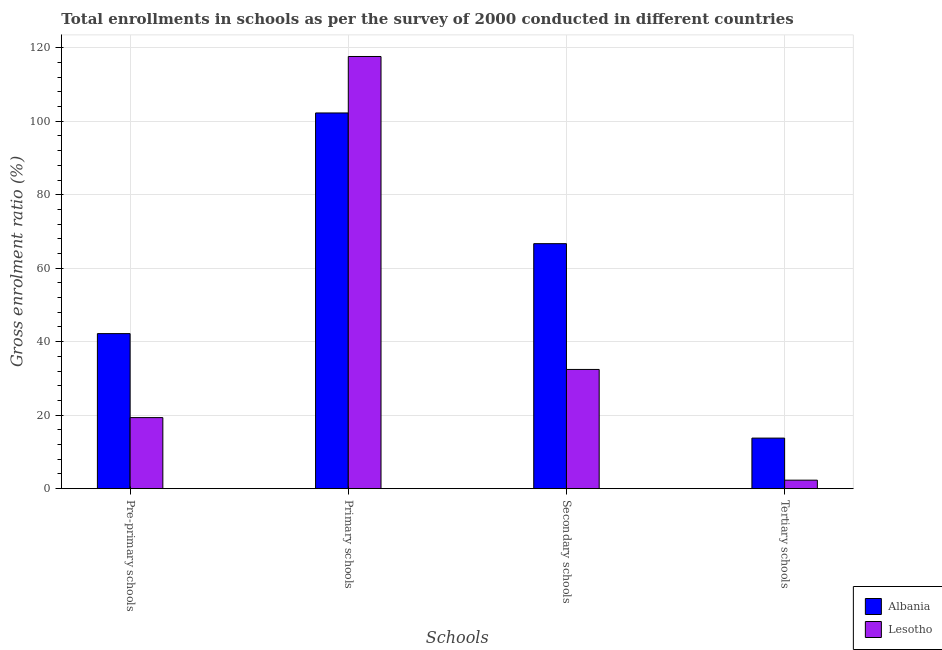How many groups of bars are there?
Keep it short and to the point. 4. Are the number of bars on each tick of the X-axis equal?
Your response must be concise. Yes. How many bars are there on the 4th tick from the right?
Your answer should be compact. 2. What is the label of the 2nd group of bars from the left?
Ensure brevity in your answer.  Primary schools. What is the gross enrolment ratio in secondary schools in Lesotho?
Make the answer very short. 32.45. Across all countries, what is the maximum gross enrolment ratio in pre-primary schools?
Offer a very short reply. 42.2. Across all countries, what is the minimum gross enrolment ratio in pre-primary schools?
Give a very brief answer. 19.34. In which country was the gross enrolment ratio in pre-primary schools maximum?
Give a very brief answer. Albania. In which country was the gross enrolment ratio in tertiary schools minimum?
Offer a terse response. Lesotho. What is the total gross enrolment ratio in primary schools in the graph?
Your answer should be very brief. 219.87. What is the difference between the gross enrolment ratio in secondary schools in Lesotho and that in Albania?
Your answer should be compact. -34.23. What is the difference between the gross enrolment ratio in pre-primary schools in Lesotho and the gross enrolment ratio in primary schools in Albania?
Provide a succinct answer. -82.91. What is the average gross enrolment ratio in primary schools per country?
Your answer should be compact. 109.94. What is the difference between the gross enrolment ratio in pre-primary schools and gross enrolment ratio in tertiary schools in Albania?
Provide a succinct answer. 28.44. What is the ratio of the gross enrolment ratio in primary schools in Lesotho to that in Albania?
Your answer should be compact. 1.15. Is the gross enrolment ratio in primary schools in Lesotho less than that in Albania?
Give a very brief answer. No. What is the difference between the highest and the second highest gross enrolment ratio in tertiary schools?
Make the answer very short. 11.45. What is the difference between the highest and the lowest gross enrolment ratio in secondary schools?
Your answer should be compact. 34.23. In how many countries, is the gross enrolment ratio in secondary schools greater than the average gross enrolment ratio in secondary schools taken over all countries?
Your answer should be compact. 1. Is it the case that in every country, the sum of the gross enrolment ratio in secondary schools and gross enrolment ratio in primary schools is greater than the sum of gross enrolment ratio in pre-primary schools and gross enrolment ratio in tertiary schools?
Provide a short and direct response. Yes. What does the 2nd bar from the left in Secondary schools represents?
Offer a terse response. Lesotho. What does the 1st bar from the right in Primary schools represents?
Give a very brief answer. Lesotho. Are all the bars in the graph horizontal?
Your answer should be compact. No. How many countries are there in the graph?
Make the answer very short. 2. Does the graph contain grids?
Your response must be concise. Yes. What is the title of the graph?
Ensure brevity in your answer.  Total enrollments in schools as per the survey of 2000 conducted in different countries. Does "Djibouti" appear as one of the legend labels in the graph?
Provide a succinct answer. No. What is the label or title of the X-axis?
Your answer should be very brief. Schools. What is the Gross enrolment ratio (%) of Albania in Pre-primary schools?
Give a very brief answer. 42.2. What is the Gross enrolment ratio (%) of Lesotho in Pre-primary schools?
Keep it short and to the point. 19.34. What is the Gross enrolment ratio (%) in Albania in Primary schools?
Your response must be concise. 102.25. What is the Gross enrolment ratio (%) of Lesotho in Primary schools?
Your response must be concise. 117.62. What is the Gross enrolment ratio (%) of Albania in Secondary schools?
Make the answer very short. 66.68. What is the Gross enrolment ratio (%) of Lesotho in Secondary schools?
Offer a terse response. 32.45. What is the Gross enrolment ratio (%) in Albania in Tertiary schools?
Ensure brevity in your answer.  13.76. What is the Gross enrolment ratio (%) of Lesotho in Tertiary schools?
Offer a terse response. 2.31. Across all Schools, what is the maximum Gross enrolment ratio (%) of Albania?
Offer a terse response. 102.25. Across all Schools, what is the maximum Gross enrolment ratio (%) of Lesotho?
Provide a succinct answer. 117.62. Across all Schools, what is the minimum Gross enrolment ratio (%) of Albania?
Your answer should be compact. 13.76. Across all Schools, what is the minimum Gross enrolment ratio (%) in Lesotho?
Offer a terse response. 2.31. What is the total Gross enrolment ratio (%) in Albania in the graph?
Provide a short and direct response. 224.89. What is the total Gross enrolment ratio (%) in Lesotho in the graph?
Offer a very short reply. 171.72. What is the difference between the Gross enrolment ratio (%) in Albania in Pre-primary schools and that in Primary schools?
Your answer should be compact. -60.05. What is the difference between the Gross enrolment ratio (%) of Lesotho in Pre-primary schools and that in Primary schools?
Give a very brief answer. -98.28. What is the difference between the Gross enrolment ratio (%) in Albania in Pre-primary schools and that in Secondary schools?
Offer a terse response. -24.48. What is the difference between the Gross enrolment ratio (%) in Lesotho in Pre-primary schools and that in Secondary schools?
Provide a short and direct response. -13.11. What is the difference between the Gross enrolment ratio (%) of Albania in Pre-primary schools and that in Tertiary schools?
Give a very brief answer. 28.44. What is the difference between the Gross enrolment ratio (%) of Lesotho in Pre-primary schools and that in Tertiary schools?
Give a very brief answer. 17.03. What is the difference between the Gross enrolment ratio (%) of Albania in Primary schools and that in Secondary schools?
Provide a short and direct response. 35.57. What is the difference between the Gross enrolment ratio (%) of Lesotho in Primary schools and that in Secondary schools?
Your response must be concise. 85.17. What is the difference between the Gross enrolment ratio (%) in Albania in Primary schools and that in Tertiary schools?
Ensure brevity in your answer.  88.49. What is the difference between the Gross enrolment ratio (%) of Lesotho in Primary schools and that in Tertiary schools?
Your answer should be very brief. 115.31. What is the difference between the Gross enrolment ratio (%) of Albania in Secondary schools and that in Tertiary schools?
Your response must be concise. 52.92. What is the difference between the Gross enrolment ratio (%) in Lesotho in Secondary schools and that in Tertiary schools?
Give a very brief answer. 30.13. What is the difference between the Gross enrolment ratio (%) of Albania in Pre-primary schools and the Gross enrolment ratio (%) of Lesotho in Primary schools?
Keep it short and to the point. -75.42. What is the difference between the Gross enrolment ratio (%) in Albania in Pre-primary schools and the Gross enrolment ratio (%) in Lesotho in Secondary schools?
Your answer should be very brief. 9.75. What is the difference between the Gross enrolment ratio (%) of Albania in Pre-primary schools and the Gross enrolment ratio (%) of Lesotho in Tertiary schools?
Your answer should be very brief. 39.89. What is the difference between the Gross enrolment ratio (%) in Albania in Primary schools and the Gross enrolment ratio (%) in Lesotho in Secondary schools?
Make the answer very short. 69.8. What is the difference between the Gross enrolment ratio (%) in Albania in Primary schools and the Gross enrolment ratio (%) in Lesotho in Tertiary schools?
Your response must be concise. 99.94. What is the difference between the Gross enrolment ratio (%) in Albania in Secondary schools and the Gross enrolment ratio (%) in Lesotho in Tertiary schools?
Make the answer very short. 64.36. What is the average Gross enrolment ratio (%) in Albania per Schools?
Provide a short and direct response. 56.22. What is the average Gross enrolment ratio (%) in Lesotho per Schools?
Your response must be concise. 42.93. What is the difference between the Gross enrolment ratio (%) of Albania and Gross enrolment ratio (%) of Lesotho in Pre-primary schools?
Keep it short and to the point. 22.86. What is the difference between the Gross enrolment ratio (%) in Albania and Gross enrolment ratio (%) in Lesotho in Primary schools?
Ensure brevity in your answer.  -15.37. What is the difference between the Gross enrolment ratio (%) in Albania and Gross enrolment ratio (%) in Lesotho in Secondary schools?
Give a very brief answer. 34.23. What is the difference between the Gross enrolment ratio (%) of Albania and Gross enrolment ratio (%) of Lesotho in Tertiary schools?
Your response must be concise. 11.45. What is the ratio of the Gross enrolment ratio (%) in Albania in Pre-primary schools to that in Primary schools?
Your answer should be very brief. 0.41. What is the ratio of the Gross enrolment ratio (%) in Lesotho in Pre-primary schools to that in Primary schools?
Offer a very short reply. 0.16. What is the ratio of the Gross enrolment ratio (%) of Albania in Pre-primary schools to that in Secondary schools?
Your answer should be very brief. 0.63. What is the ratio of the Gross enrolment ratio (%) of Lesotho in Pre-primary schools to that in Secondary schools?
Your response must be concise. 0.6. What is the ratio of the Gross enrolment ratio (%) in Albania in Pre-primary schools to that in Tertiary schools?
Keep it short and to the point. 3.07. What is the ratio of the Gross enrolment ratio (%) in Lesotho in Pre-primary schools to that in Tertiary schools?
Provide a short and direct response. 8.36. What is the ratio of the Gross enrolment ratio (%) of Albania in Primary schools to that in Secondary schools?
Your response must be concise. 1.53. What is the ratio of the Gross enrolment ratio (%) of Lesotho in Primary schools to that in Secondary schools?
Offer a terse response. 3.62. What is the ratio of the Gross enrolment ratio (%) of Albania in Primary schools to that in Tertiary schools?
Make the answer very short. 7.43. What is the ratio of the Gross enrolment ratio (%) in Lesotho in Primary schools to that in Tertiary schools?
Ensure brevity in your answer.  50.82. What is the ratio of the Gross enrolment ratio (%) of Albania in Secondary schools to that in Tertiary schools?
Provide a short and direct response. 4.84. What is the ratio of the Gross enrolment ratio (%) of Lesotho in Secondary schools to that in Tertiary schools?
Your answer should be very brief. 14.02. What is the difference between the highest and the second highest Gross enrolment ratio (%) of Albania?
Your answer should be very brief. 35.57. What is the difference between the highest and the second highest Gross enrolment ratio (%) of Lesotho?
Provide a succinct answer. 85.17. What is the difference between the highest and the lowest Gross enrolment ratio (%) of Albania?
Keep it short and to the point. 88.49. What is the difference between the highest and the lowest Gross enrolment ratio (%) in Lesotho?
Give a very brief answer. 115.31. 